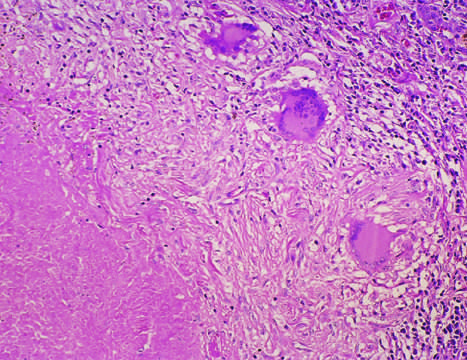s acute promyelocytic leukemia-bone marrow the usual response in individuals who develop cell-mediated immunity to the organism?
Answer the question using a single word or phrase. No 